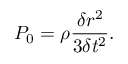Convert formula to latex. <formula><loc_0><loc_0><loc_500><loc_500>P _ { 0 } = \rho \frac { \delta r ^ { 2 } } { 3 \delta t ^ { 2 } } .</formula> 